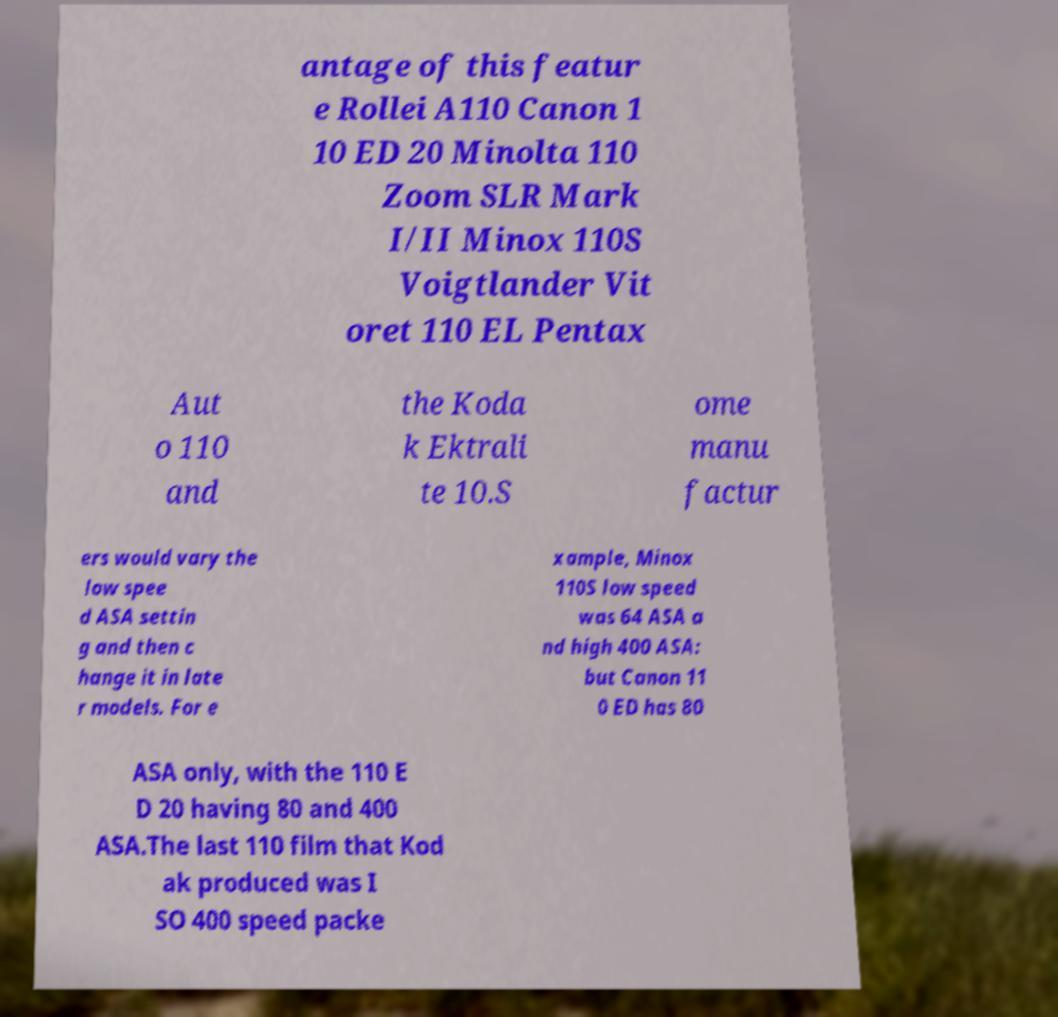I need the written content from this picture converted into text. Can you do that? antage of this featur e Rollei A110 Canon 1 10 ED 20 Minolta 110 Zoom SLR Mark I/II Minox 110S Voigtlander Vit oret 110 EL Pentax Aut o 110 and the Koda k Ektrali te 10.S ome manu factur ers would vary the low spee d ASA settin g and then c hange it in late r models. For e xample, Minox 110S low speed was 64 ASA a nd high 400 ASA: but Canon 11 0 ED has 80 ASA only, with the 110 E D 20 having 80 and 400 ASA.The last 110 film that Kod ak produced was I SO 400 speed packe 